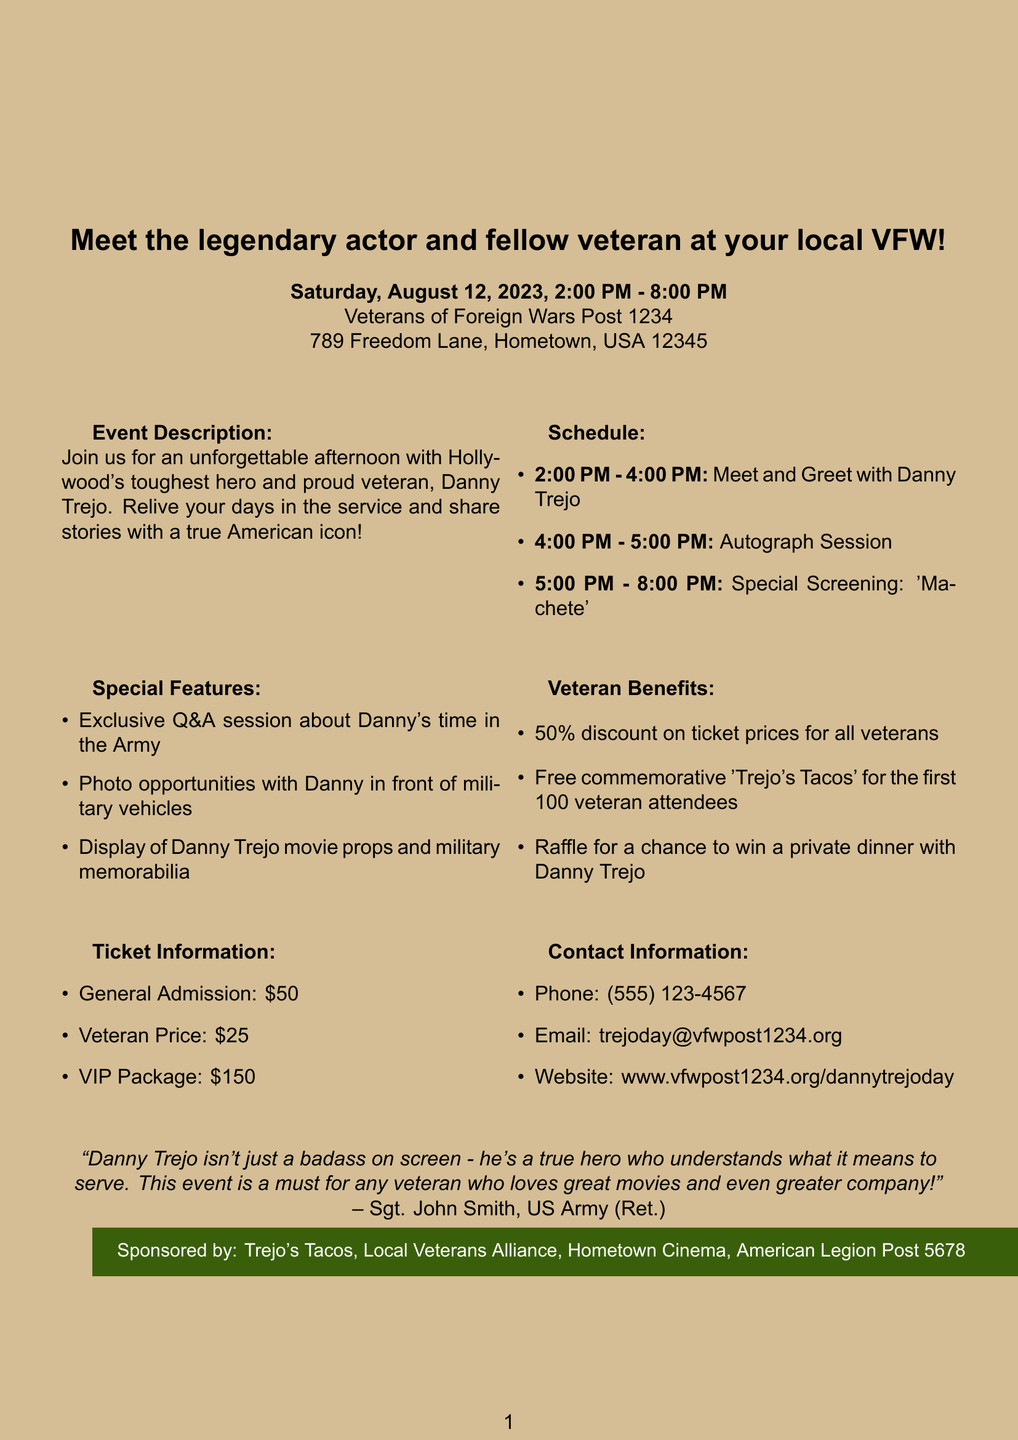What is the title of the event? The title of the event is stated at the top of the document as "Danny Trejo: From Warrior to Warrior".
Answer: Danny Trejo: From Warrior to Warrior When is the meet-and-greet scheduled? The document specifies the event date and time as Saturday, August 12, 2023, from 2:00 PM to 8:00 PM.
Answer: Saturday, August 12, 2023, 2:00 PM - 8:00 PM Where is the event taking place? The address provided in the document indicates the event location is at Veterans of Foreign Wars Post 1234, 789 Freedom Lane, Hometown, USA 12345.
Answer: Veterans of Foreign Wars Post 1234, 789 Freedom Lane, Hometown, USA 12345 What special feature includes a Q&A session? The document highlights an exclusive Q&A session about Danny's time in the Army as one of the special features.
Answer: Exclusive Q&A session about Danny's time in the Army How much is the veteran ticket price? The veteran price mentioned in the document is clearly noted as $25.
Answer: $25 What unique opportunity is available for the first 100 veteran attendees? The document states that the first 100 veteran attendees will receive a free commemorative 'Trejo's Tacos'.
Answer: Free commemorative 'Trejo's Tacos' What is included in the VIP package? The document lists priority seating, exclusive Trejo merchandise, and private meet-and-greet as inclusions in the VIP package for $150.
Answer: Priority seating, exclusive Trejo merchandise, and private meet-and-greet Who is the testimonial author? The author of the testimonial quoted in the document is named as Sgt. John Smith, US Army (Ret.).
Answer: Sgt. John Smith, US Army (Ret.) 